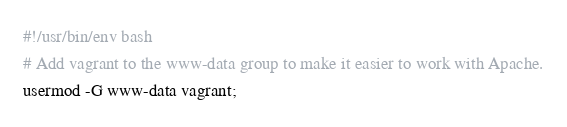<code> <loc_0><loc_0><loc_500><loc_500><_Bash_>#!/usr/bin/env bash
# Add vagrant to the www-data group to make it easier to work with Apache.
usermod -G www-data vagrant;
</code> 